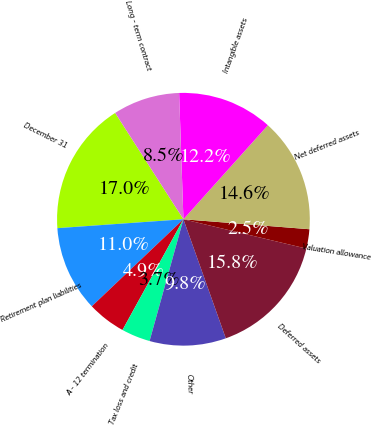Convert chart. <chart><loc_0><loc_0><loc_500><loc_500><pie_chart><fcel>December 31<fcel>Retirement plan liabilities<fcel>A - 12 termination<fcel>Tax loss and credit<fcel>Other<fcel>Deferred assets<fcel>Valuation allowance<fcel>Net deferred assets<fcel>Intangible assets<fcel>Long - term contract<nl><fcel>17.04%<fcel>10.97%<fcel>4.9%<fcel>3.69%<fcel>9.76%<fcel>15.83%<fcel>2.47%<fcel>14.61%<fcel>12.19%<fcel>8.54%<nl></chart> 